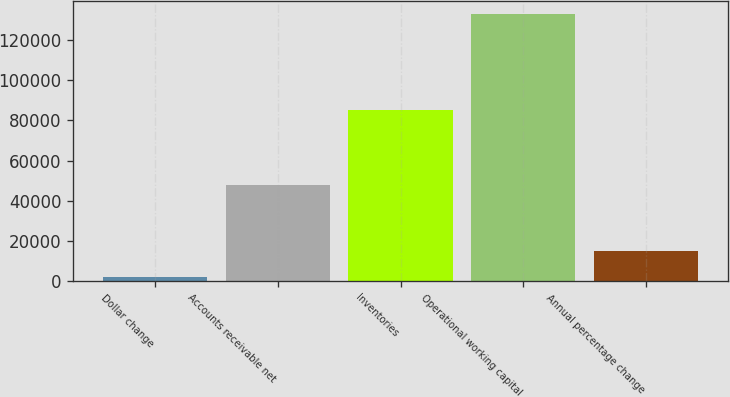Convert chart. <chart><loc_0><loc_0><loc_500><loc_500><bar_chart><fcel>Dollar change<fcel>Accounts receivable net<fcel>Inventories<fcel>Operational working capital<fcel>Annual percentage change<nl><fcel>2014<fcel>47746<fcel>85156<fcel>132902<fcel>15102.8<nl></chart> 